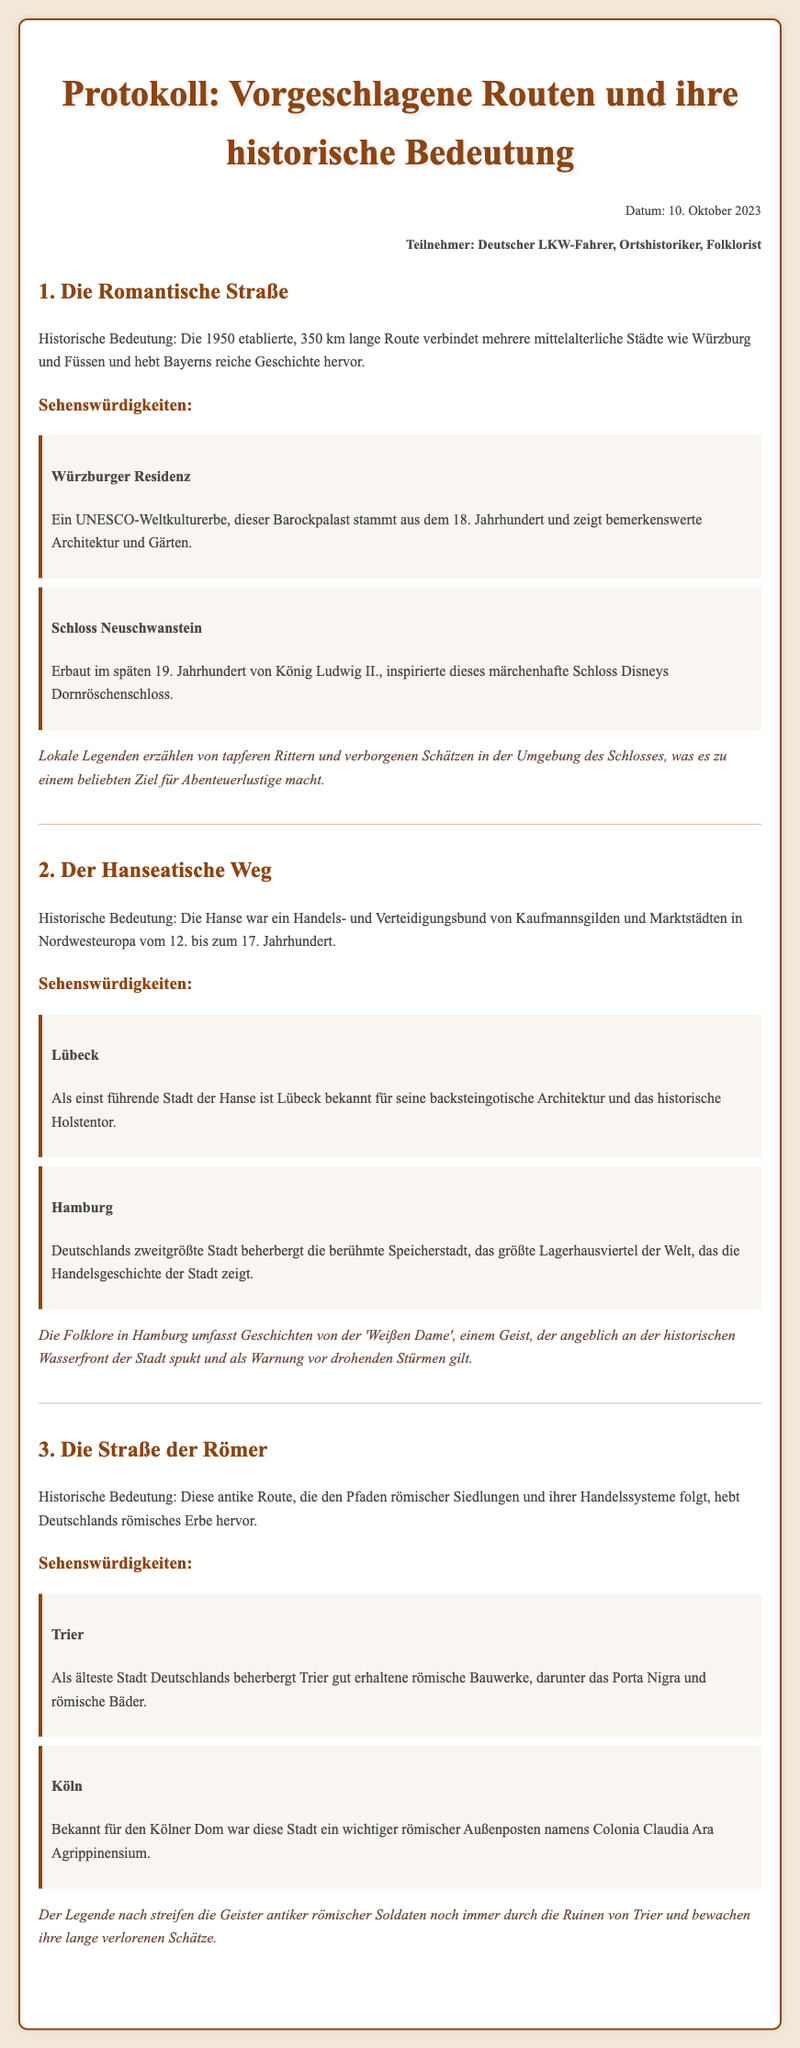Was ist die Länge der Romantischen Straße? Die Länge der Romantischen Straße beträgt 350 km.
Answer: 350 km Wann wurde die Romantische Straße etabliert? Die Romantische Straße wurde im Jahr 1950 etabliert.
Answer: 1950 Nenne eine Sehenswürdigkeit in Lübeck. Die Sehenswürdigkeit in Lübeck ist das Holstentor.
Answer: Holstentor Was ist ein UNESCO-Weltkulturerbe, das in der Romantischen Straße zu finden ist? Die Würzburger Residenz ist ein UNESCO-Weltkulturerbe.
Answer: Würzburger Residenz Welche Stadt ist bekannt für die Weiße Dame? Hamburg ist bekannt für die Weiße Dame.
Answer: Hamburg Nenne ein Beispiel für eine Folklore-Überlieferung, die mit dem Schloss Neuschwanstein in Verbindung steht. Lokale Legenden erzählen von tapferen Rittern und verborgenen Schätzen.
Answer: Verteidigung in der Nähe Was war die römische Bezeichnung für Köln? Die römische Bezeichnung für Köln war Colonia Claudia Ara Agrippinensium.
Answer: Colonia Claudia Ara Agrippinensium Wie viele Routen werden im Protokoll erwähnt? Es werden drei Routen im Protokoll erwähnt.
Answer: Drei Welches Bauwerk in Trier ist als Porta Nigra bekannt? Das Bauwerk in Trier, das als Porta Nigra bekannt ist, ist ein römisches Bauwerk.
Answer: Porta Nigra 